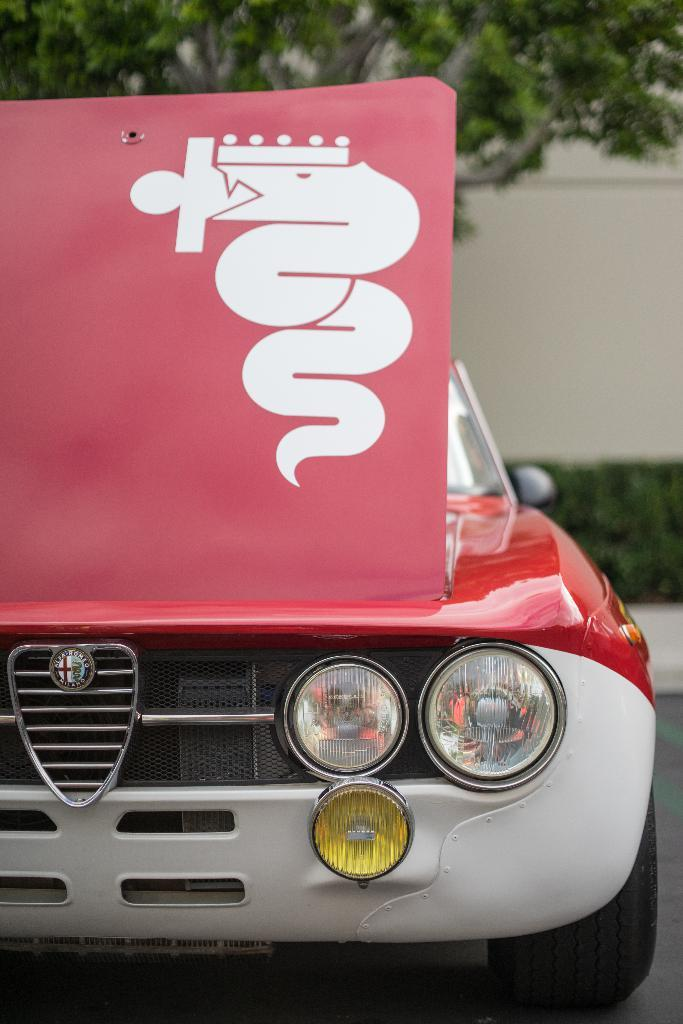What is placed on the car in the image? There is a board on a car in the image. What can be seen behind the car? There are plants visible behind the car. What type of silver jar can be seen on the board in the image? There is no silver jar present on the board in the image. 